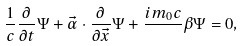<formula> <loc_0><loc_0><loc_500><loc_500>\frac { 1 } { c } \frac { \partial } { \partial t } \Psi + \vec { \alpha } \cdot \frac { \partial } { \partial \vec { x } } \Psi + \frac { i m _ { 0 } c } { } \beta \Psi = 0 ,</formula> 